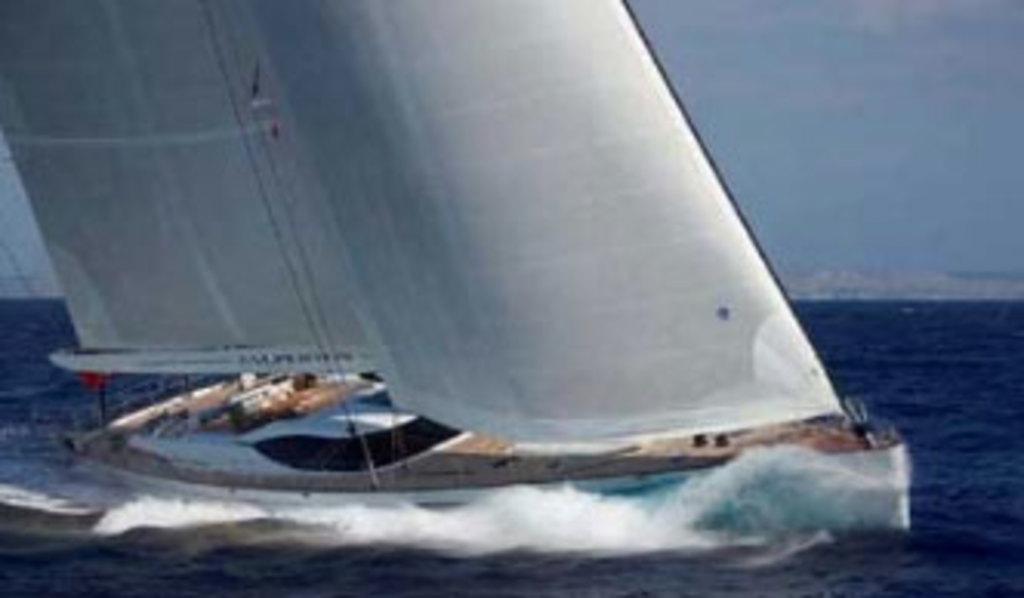In one or two sentences, can you explain what this image depicts? We can see boats above the water. In the background we can see sky. 